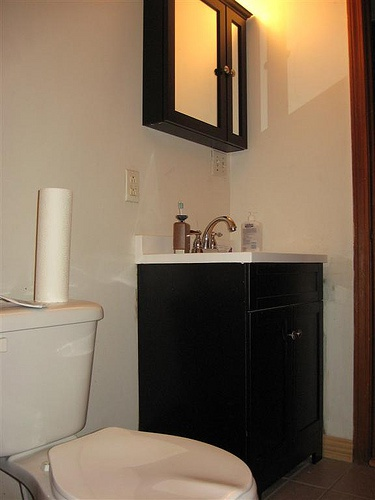Describe the objects in this image and their specific colors. I can see toilet in gray and tan tones, sink in gray and tan tones, bottle in gray and tan tones, bottle in gray and maroon tones, and toothbrush in gray, darkgray, and lightgray tones in this image. 